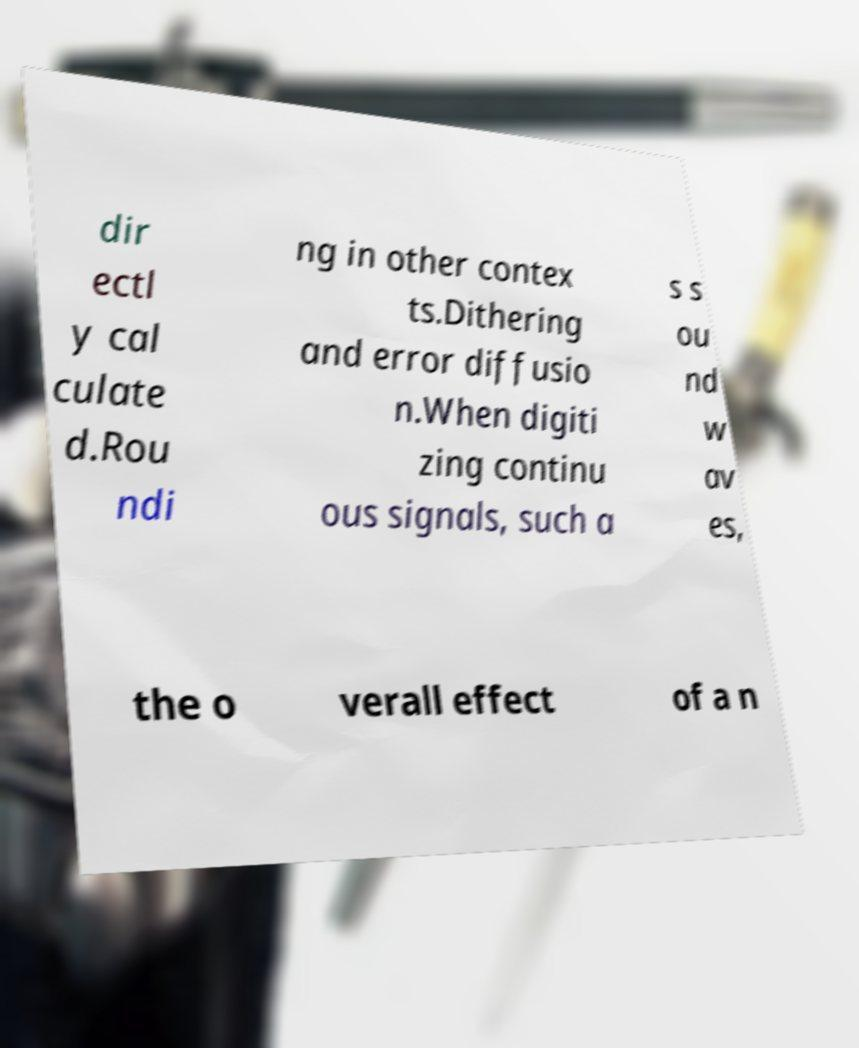There's text embedded in this image that I need extracted. Can you transcribe it verbatim? dir ectl y cal culate d.Rou ndi ng in other contex ts.Dithering and error diffusio n.When digiti zing continu ous signals, such a s s ou nd w av es, the o verall effect of a n 